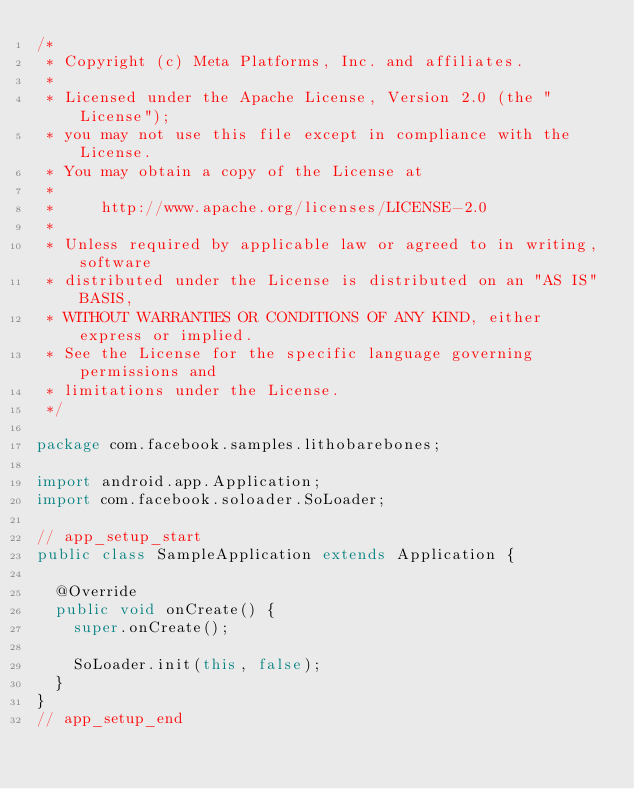Convert code to text. <code><loc_0><loc_0><loc_500><loc_500><_Java_>/*
 * Copyright (c) Meta Platforms, Inc. and affiliates.
 *
 * Licensed under the Apache License, Version 2.0 (the "License");
 * you may not use this file except in compliance with the License.
 * You may obtain a copy of the License at
 *
 *     http://www.apache.org/licenses/LICENSE-2.0
 *
 * Unless required by applicable law or agreed to in writing, software
 * distributed under the License is distributed on an "AS IS" BASIS,
 * WITHOUT WARRANTIES OR CONDITIONS OF ANY KIND, either express or implied.
 * See the License for the specific language governing permissions and
 * limitations under the License.
 */

package com.facebook.samples.lithobarebones;

import android.app.Application;
import com.facebook.soloader.SoLoader;

// app_setup_start
public class SampleApplication extends Application {

  @Override
  public void onCreate() {
    super.onCreate();

    SoLoader.init(this, false);
  }
}
// app_setup_end
</code> 